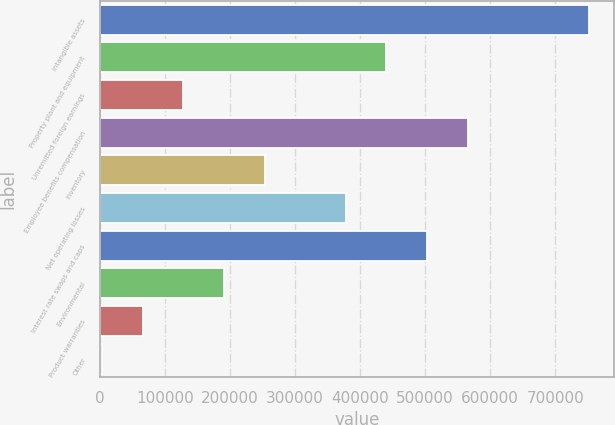Convert chart to OTSL. <chart><loc_0><loc_0><loc_500><loc_500><bar_chart><fcel>Intangible assets<fcel>Property plant and equipment<fcel>Unremitted foreign earnings<fcel>Employee benefits compensation<fcel>Inventory<fcel>Net operating losses<fcel>Interest rate swaps and caps<fcel>Environmental<fcel>Product warranties<fcel>Other<nl><fcel>752516<fcel>440308<fcel>128099<fcel>565191<fcel>252983<fcel>377866<fcel>502750<fcel>190541<fcel>65657.7<fcel>3216<nl></chart> 